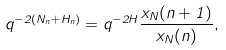<formula> <loc_0><loc_0><loc_500><loc_500>q ^ { - 2 ( N _ { n } + H _ { n } ) } = q ^ { - 2 H } \frac { x _ { N } ( n + 1 ) } { x _ { N } ( n ) } ,</formula> 